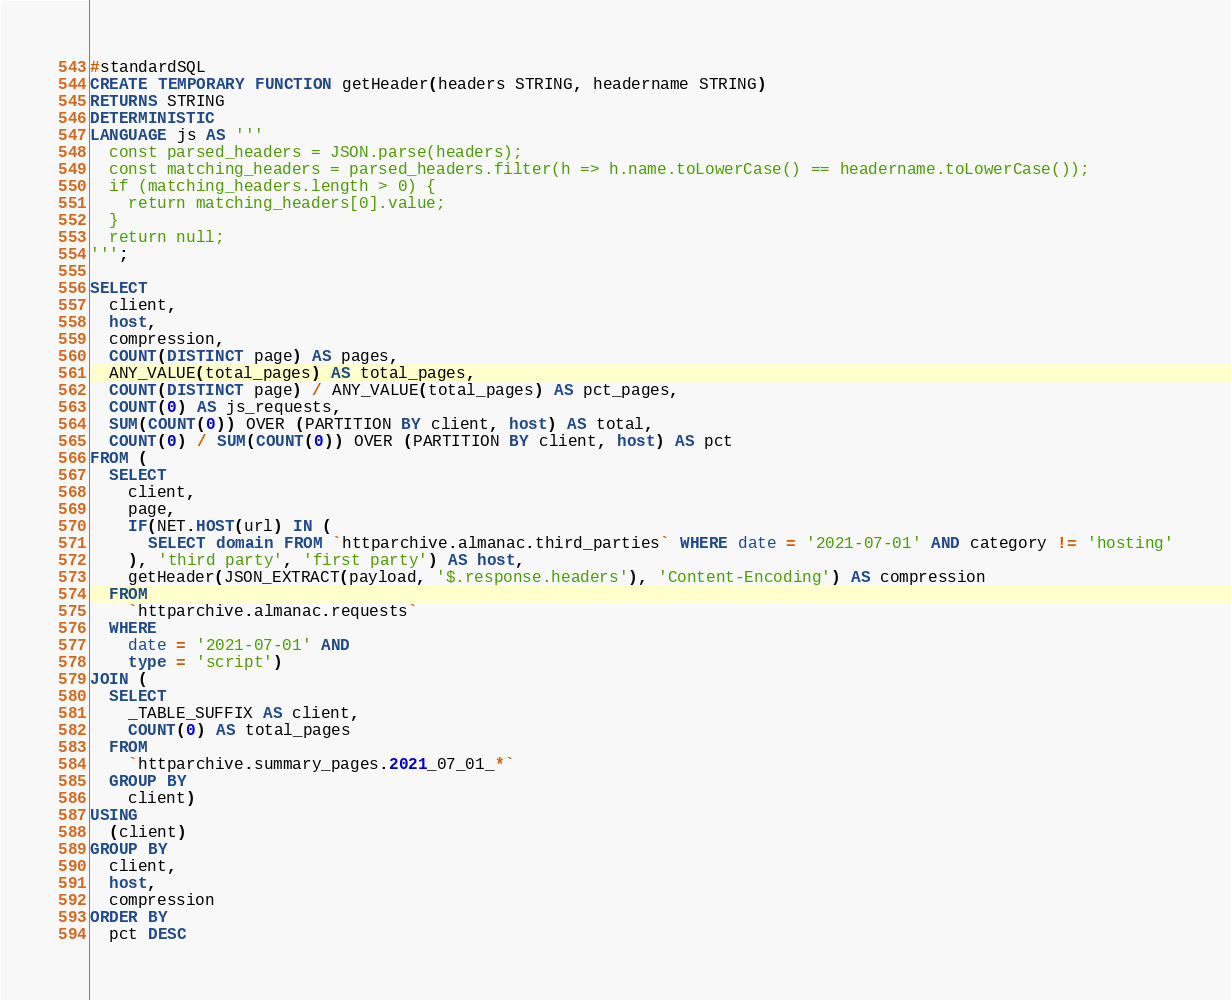Convert code to text. <code><loc_0><loc_0><loc_500><loc_500><_SQL_>#standardSQL
CREATE TEMPORARY FUNCTION getHeader(headers STRING, headername STRING)
RETURNS STRING
DETERMINISTIC
LANGUAGE js AS '''
  const parsed_headers = JSON.parse(headers);
  const matching_headers = parsed_headers.filter(h => h.name.toLowerCase() == headername.toLowerCase());
  if (matching_headers.length > 0) {
    return matching_headers[0].value;
  }
  return null;
''';

SELECT
  client,
  host,
  compression,
  COUNT(DISTINCT page) AS pages,
  ANY_VALUE(total_pages) AS total_pages,
  COUNT(DISTINCT page) / ANY_VALUE(total_pages) AS pct_pages,
  COUNT(0) AS js_requests,
  SUM(COUNT(0)) OVER (PARTITION BY client, host) AS total,
  COUNT(0) / SUM(COUNT(0)) OVER (PARTITION BY client, host) AS pct
FROM (
  SELECT
    client,
    page,
    IF(NET.HOST(url) IN (
      SELECT domain FROM `httparchive.almanac.third_parties` WHERE date = '2021-07-01' AND category != 'hosting'
    ), 'third party', 'first party') AS host,
    getHeader(JSON_EXTRACT(payload, '$.response.headers'), 'Content-Encoding') AS compression
  FROM
    `httparchive.almanac.requests`
  WHERE
    date = '2021-07-01' AND
    type = 'script')
JOIN (
  SELECT
    _TABLE_SUFFIX AS client,
    COUNT(0) AS total_pages
  FROM
    `httparchive.summary_pages.2021_07_01_*`
  GROUP BY
    client)
USING
  (client)
GROUP BY
  client,
  host,
  compression
ORDER BY
  pct DESC
</code> 